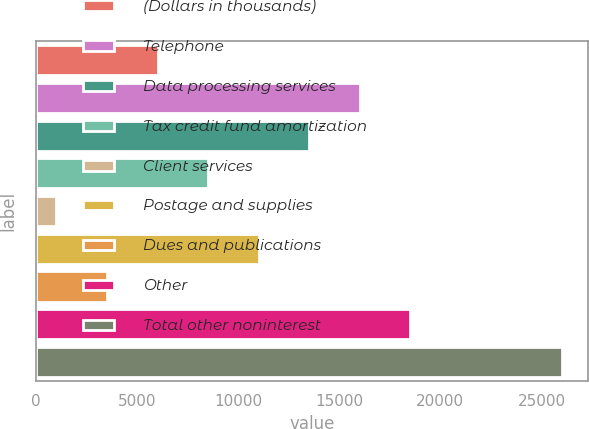<chart> <loc_0><loc_0><loc_500><loc_500><bar_chart><fcel>(Dollars in thousands)<fcel>Telephone<fcel>Data processing services<fcel>Tax credit fund amortization<fcel>Client services<fcel>Postage and supplies<fcel>Dues and publications<fcel>Other<fcel>Total other noninterest<nl><fcel>6019<fcel>16013<fcel>13514.5<fcel>8517.5<fcel>1022<fcel>11016<fcel>3520.5<fcel>18511.5<fcel>26007<nl></chart> 